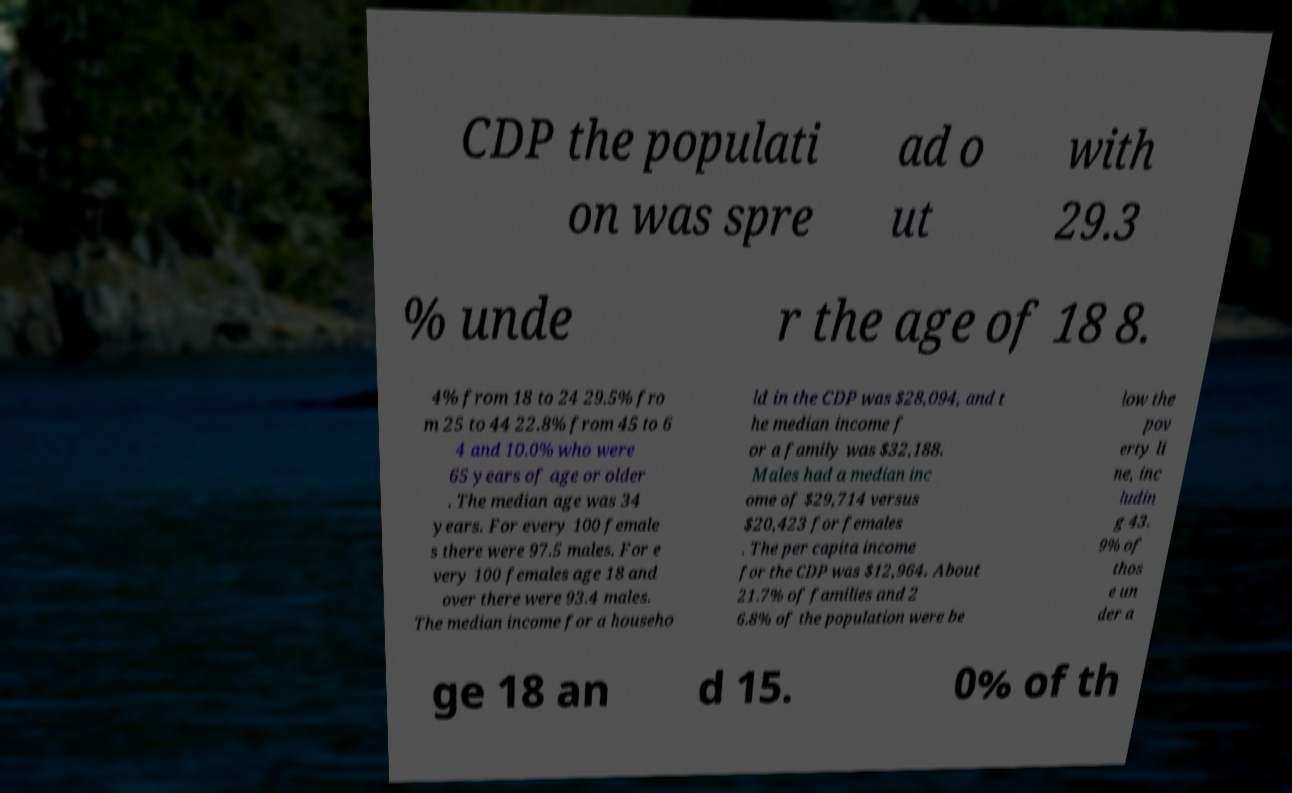Can you read and provide the text displayed in the image?This photo seems to have some interesting text. Can you extract and type it out for me? CDP the populati on was spre ad o ut with 29.3 % unde r the age of 18 8. 4% from 18 to 24 29.5% fro m 25 to 44 22.8% from 45 to 6 4 and 10.0% who were 65 years of age or older . The median age was 34 years. For every 100 female s there were 97.5 males. For e very 100 females age 18 and over there were 93.4 males. The median income for a househo ld in the CDP was $28,094, and t he median income f or a family was $32,188. Males had a median inc ome of $29,714 versus $20,423 for females . The per capita income for the CDP was $12,964. About 21.7% of families and 2 6.8% of the population were be low the pov erty li ne, inc ludin g 43. 9% of thos e un der a ge 18 an d 15. 0% of th 